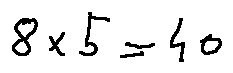<formula> <loc_0><loc_0><loc_500><loc_500>8 \times 5 = 4 0</formula> 